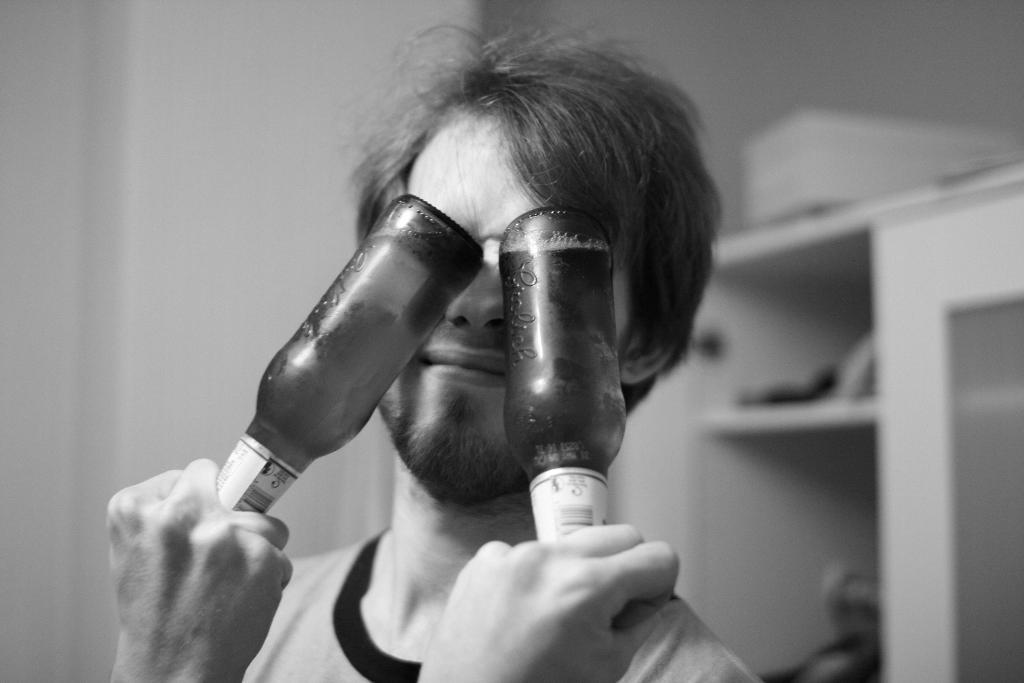Who is present in the image? There is a man in the image. What is the man holding in his hands? The man is holding two bottles with his hands. What can be seen in the background of the image? There is a wall in the background of the image. What type of cloth is draped over the square in the image? There is no cloth or square present in the image. 